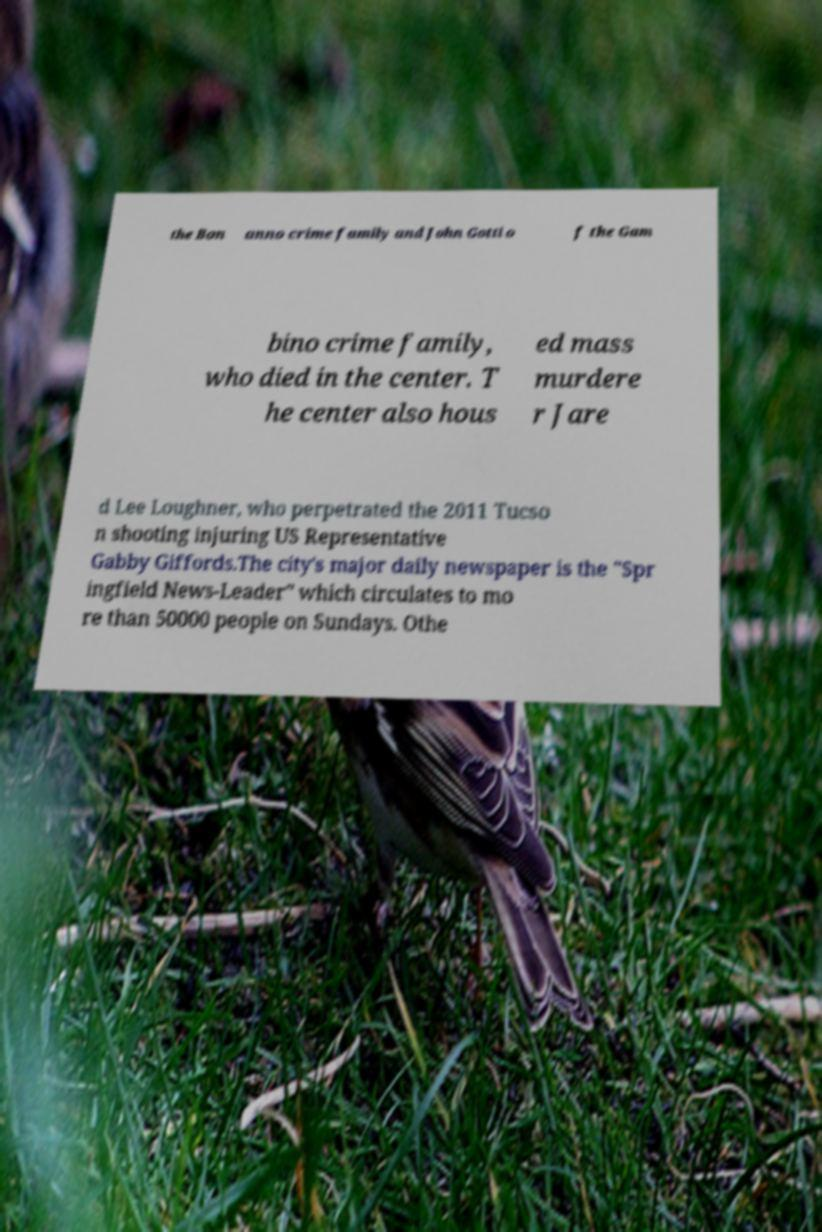For documentation purposes, I need the text within this image transcribed. Could you provide that? the Bon anno crime family and John Gotti o f the Gam bino crime family, who died in the center. T he center also hous ed mass murdere r Jare d Lee Loughner, who perpetrated the 2011 Tucso n shooting injuring US Representative Gabby Giffords.The city's major daily newspaper is the "Spr ingfield News-Leader" which circulates to mo re than 50000 people on Sundays. Othe 